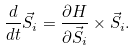<formula> <loc_0><loc_0><loc_500><loc_500>\frac { d } { d t } \vec { S } _ { i } = \frac { \partial H } { \partial \vec { S } _ { i } } \times \vec { S } _ { i } .</formula> 